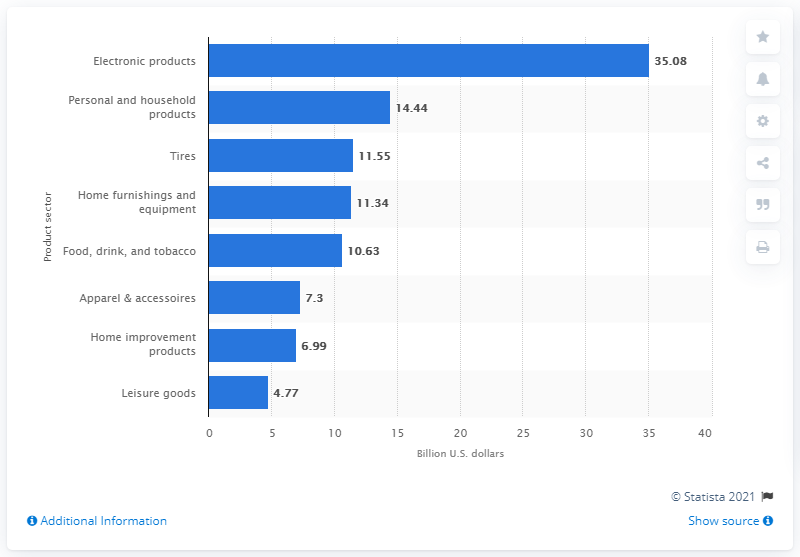Draw attention to some important aspects in this diagram. In 2013, the average size of the world's leading electronic products companies was 35.08. 